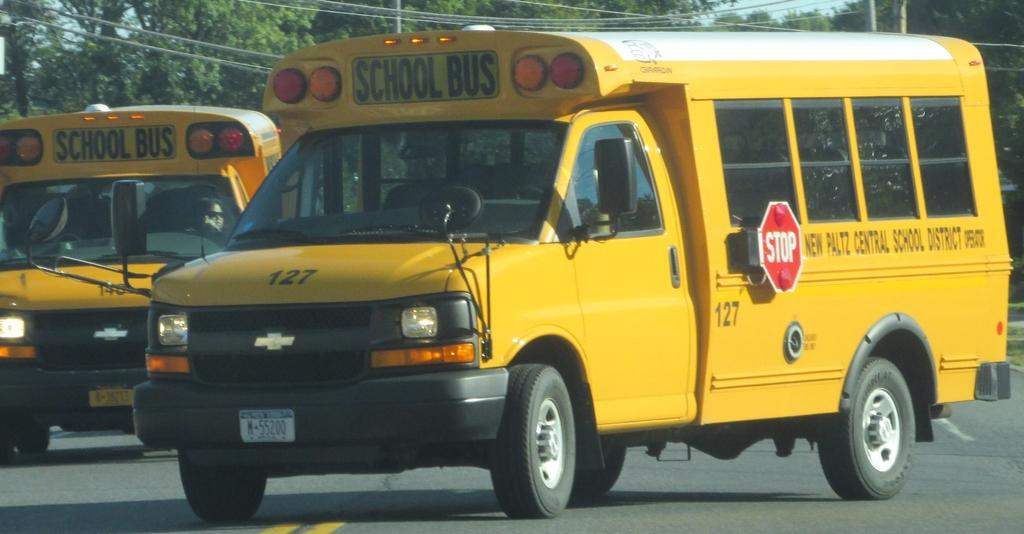<image>
Summarize the visual content of the image. A school bus for New Paltz Central School District is on the road. 